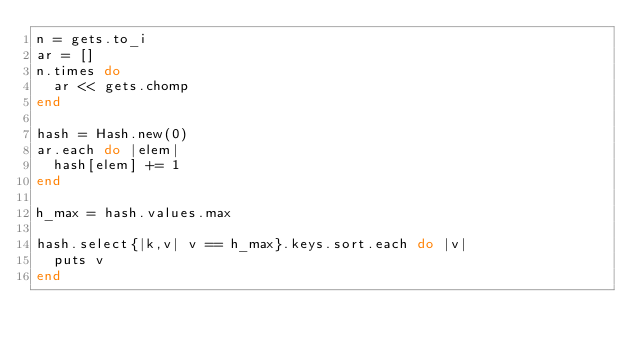Convert code to text. <code><loc_0><loc_0><loc_500><loc_500><_Ruby_>n = gets.to_i
ar = []
n.times do
  ar << gets.chomp
end

hash = Hash.new(0)
ar.each do |elem|
  hash[elem] += 1
end

h_max = hash.values.max

hash.select{|k,v| v == h_max}.keys.sort.each do |v|
  puts v
end
</code> 